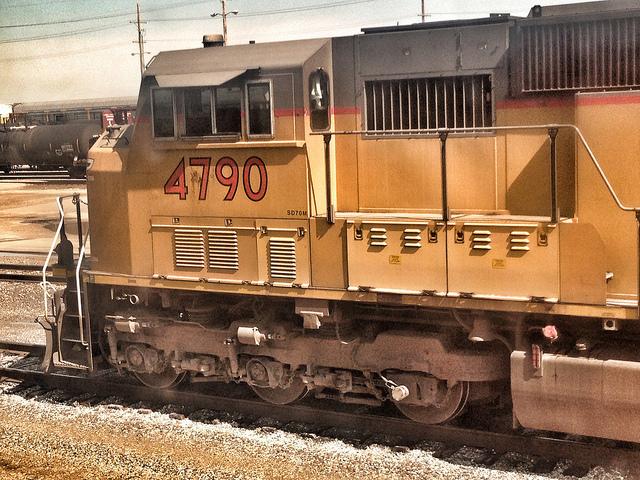What color makes up most of the train?
Short answer required. Yellow. What numbers are on the side of the train?
Answer briefly. 4790. Is this an airplane?
Answer briefly. No. 